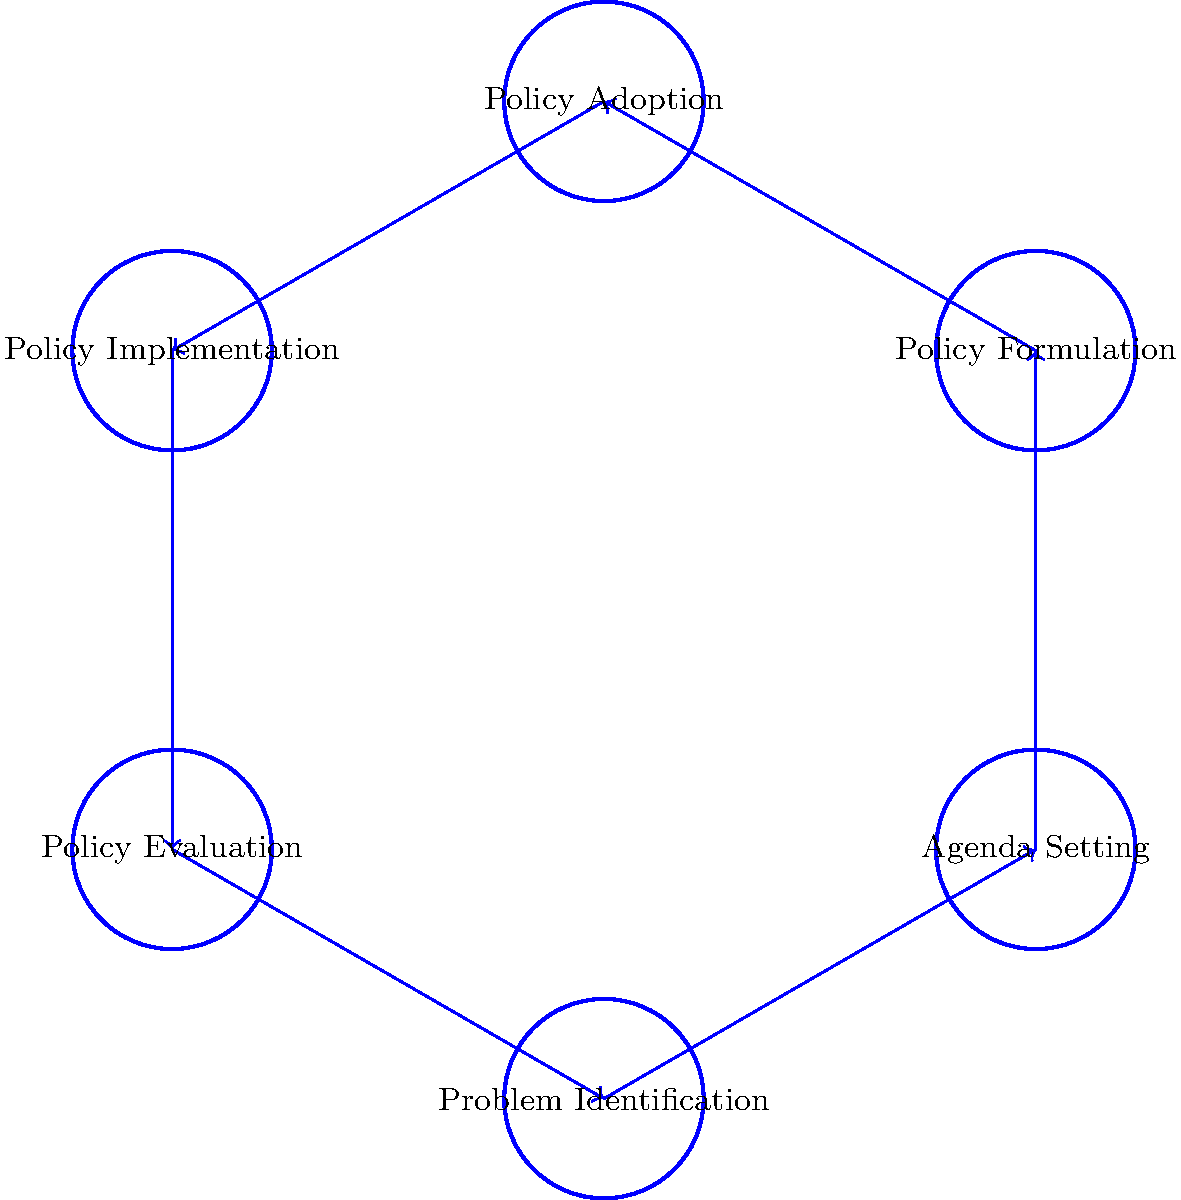In the UK government's policy-making process, which stage typically follows "Policy Adoption" and precedes "Policy Evaluation"? To answer this question, we need to analyze the circular diagram illustrating the stages of the policy-making process in the UK government. The diagram shows six stages in a cyclical order:

1. Problem Identification
2. Agenda Setting
3. Policy Formulation
4. Policy Adoption
5. Policy Implementation
6. Policy Evaluation

The question asks for the stage that follows "Policy Adoption" and precedes "Policy Evaluation". By examining the diagram, we can see that:

1. "Policy Adoption" is the fourth stage in the cycle.
2. The stage immediately following "Policy Adoption" is "Policy Implementation".
3. "Policy Evaluation" comes after "Policy Implementation".

Therefore, the stage that follows "Policy Adoption" and precedes "Policy Evaluation" is "Policy Implementation".

This order reflects the logical progression of the policy-making process:
- After a policy is adopted (Policy Adoption), it needs to be put into action (Policy Implementation).
- Only after implementation can the effects and outcomes of the policy be assessed (Policy Evaluation).

Understanding this sequence is crucial for analyzing the policy-making process, as it demonstrates how policies move from decision to action and then to assessment, potentially leading to further refinement or new policy cycles.
Answer: Policy Implementation 